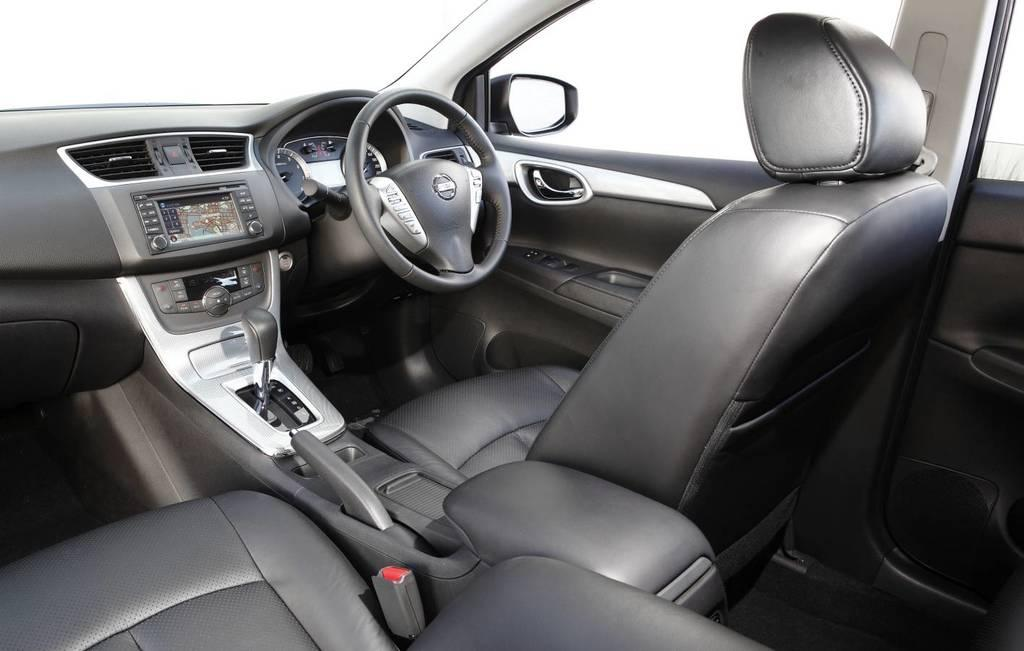What is the primary object in the image? The image contains parts of a vehicle, including a steering wheel, gear, display, speedometer, seats, and side mirror. Can you describe the steering wheel in the image? The image shows a steering wheel, which is a component used for controlling the direction of the vehicle. What type of information might be displayed on the display in the image? The display in the image might show information such as speed, distance, or navigation directions. How many seats are visible in the image? There are seats in the image, but the exact number is not specified. What is the belief system of the chin in the image? There is no chin present in the image; it contains parts of a vehicle. 